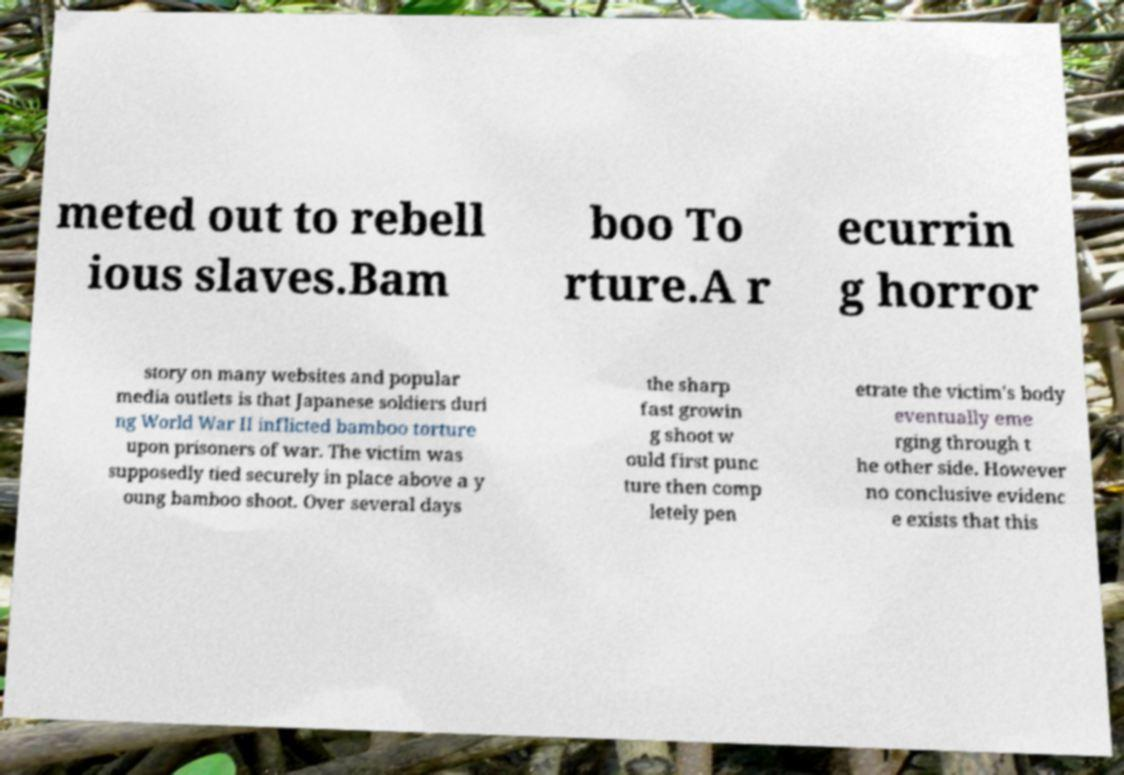There's text embedded in this image that I need extracted. Can you transcribe it verbatim? meted out to rebell ious slaves.Bam boo To rture.A r ecurrin g horror story on many websites and popular media outlets is that Japanese soldiers duri ng World War II inflicted bamboo torture upon prisoners of war. The victim was supposedly tied securely in place above a y oung bamboo shoot. Over several days the sharp fast growin g shoot w ould first punc ture then comp letely pen etrate the victim's body eventually eme rging through t he other side. However no conclusive evidenc e exists that this 